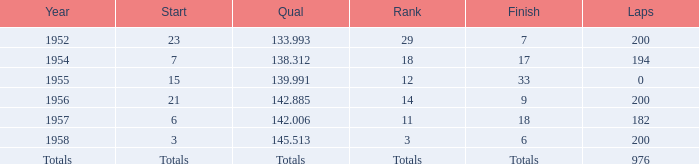In 1957, what rank did jimmy reece attain? 18.0. 